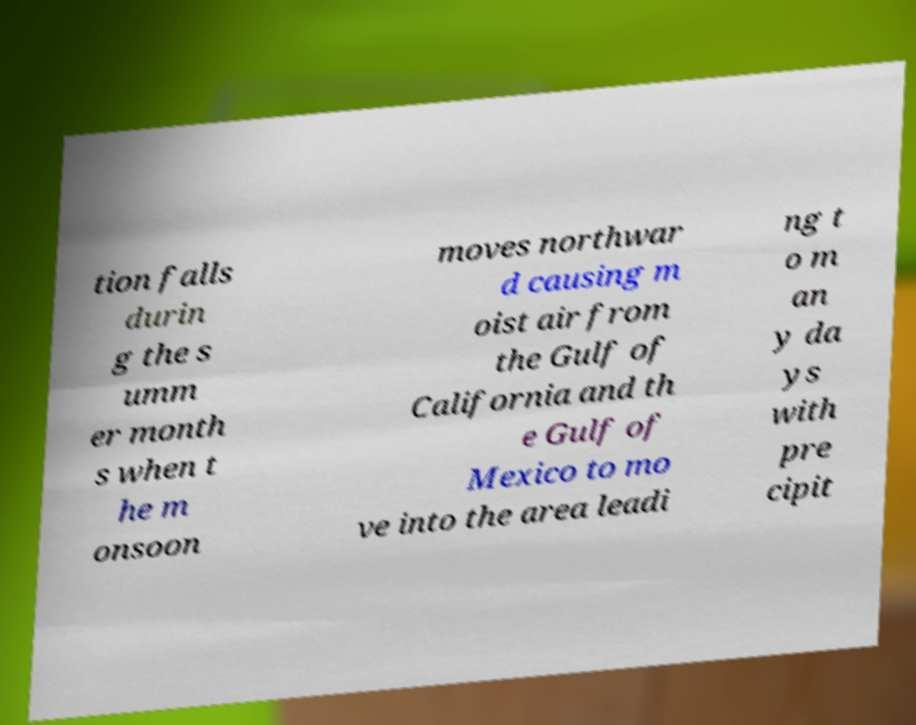Can you read and provide the text displayed in the image?This photo seems to have some interesting text. Can you extract and type it out for me? tion falls durin g the s umm er month s when t he m onsoon moves northwar d causing m oist air from the Gulf of California and th e Gulf of Mexico to mo ve into the area leadi ng t o m an y da ys with pre cipit 